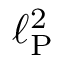<formula> <loc_0><loc_0><loc_500><loc_500>\ell _ { P } ^ { 2 }</formula> 